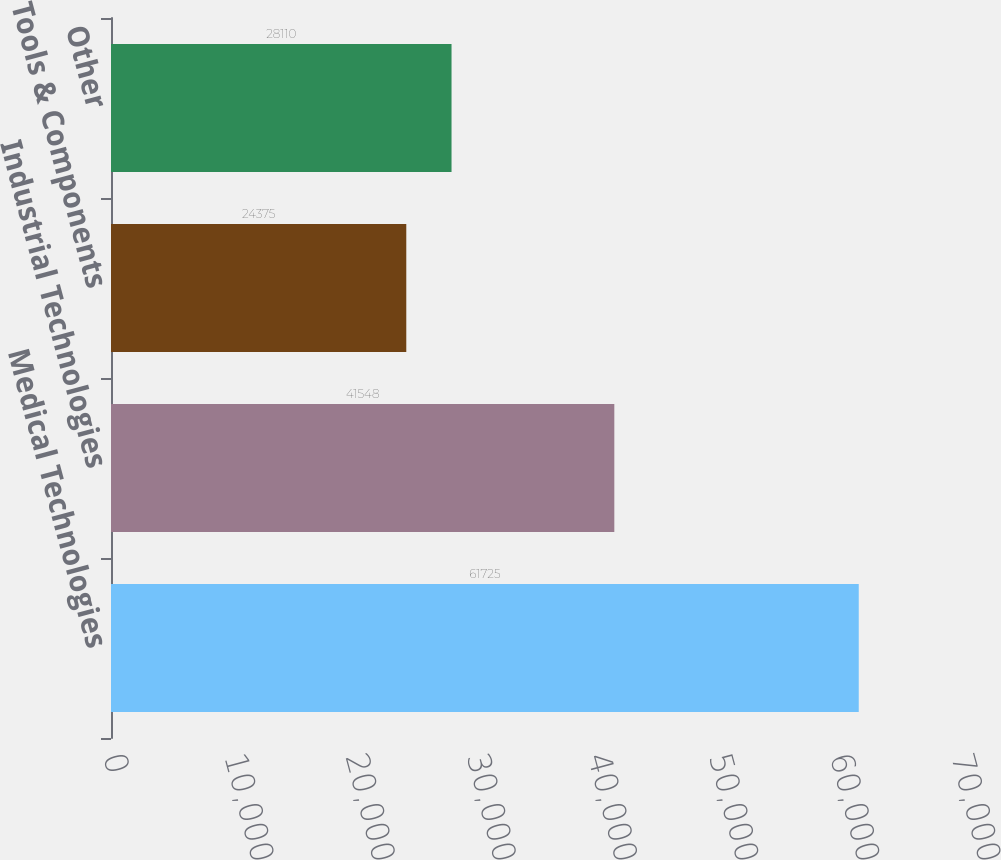Convert chart to OTSL. <chart><loc_0><loc_0><loc_500><loc_500><bar_chart><fcel>Medical Technologies<fcel>Industrial Technologies<fcel>Tools & Components<fcel>Other<nl><fcel>61725<fcel>41548<fcel>24375<fcel>28110<nl></chart> 